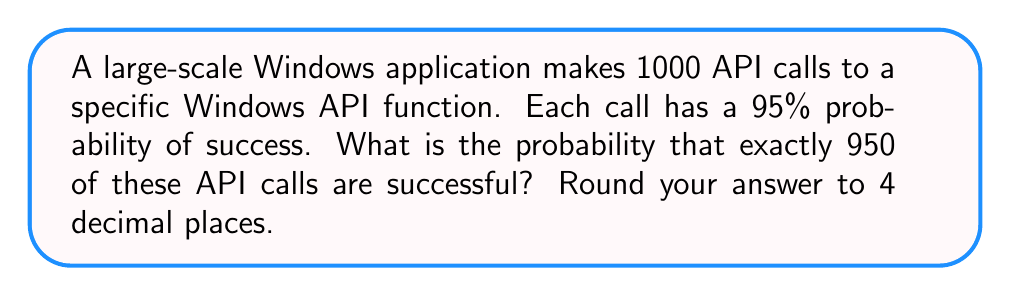What is the answer to this math problem? To solve this problem, we'll use the binomial distribution formula, as we're dealing with a fixed number of independent trials (API calls) with two possible outcomes (success or failure) and a constant probability of success.

The binomial distribution probability mass function is:

$$P(X = k) = \binom{n}{k} p^k (1-p)^{n-k}$$

Where:
$n$ = number of trials
$k$ = number of successes
$p$ = probability of success on each trial

Given:
$n = 1000$ (total API calls)
$k = 950$ (successful calls we're interested in)
$p = 0.95$ (95% probability of success)

Step 1: Calculate $\binom{n}{k}$
$$\binom{1000}{950} = \frac{1000!}{950!(1000-950)!} = \frac{1000!}{950!50!}$$

Step 2: Substitute values into the binomial distribution formula
$$P(X = 950) = \binom{1000}{950} (0.95)^{950} (1-0.95)^{1000-950}$$

Step 3: Simplify
$$P(X = 950) = \binom{1000}{950} (0.95)^{950} (0.05)^{50}$$

Step 4: Calculate using a computer or calculator (due to large numbers)
$$P(X = 950) \approx 0.0585833$$

Step 5: Round to 4 decimal places
$$P(X = 950) \approx 0.0586$$
Answer: 0.0586 